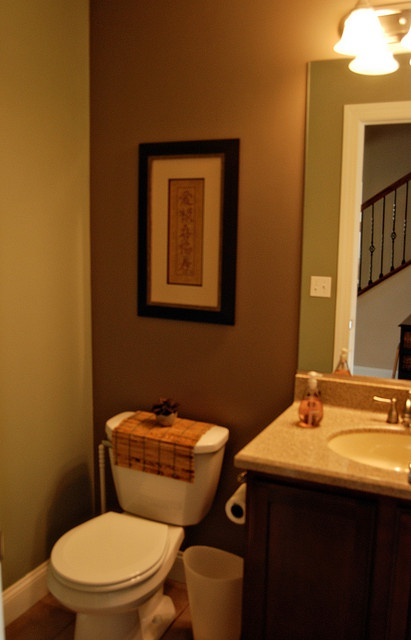Describe the objects in this image and their specific colors. I can see toilet in olive, tan, brown, and maroon tones, sink in olive, orange, red, and maroon tones, and bottle in olive, brown, red, maroon, and orange tones in this image. 